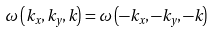Convert formula to latex. <formula><loc_0><loc_0><loc_500><loc_500>\omega \left ( k _ { x } , k _ { y } , k \right ) = \omega \left ( - k _ { x } , - k _ { y } , - k \right )</formula> 